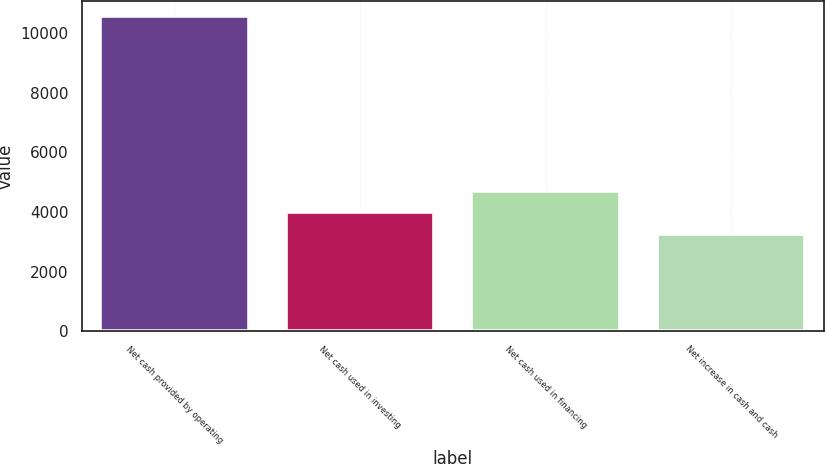Convert chart. <chart><loc_0><loc_0><loc_500><loc_500><bar_chart><fcel>Net cash provided by operating<fcel>Net cash used in investing<fcel>Net cash used in financing<fcel>Net increase in cash and cash<nl><fcel>10571<fcel>3989.3<fcel>4720.6<fcel>3258<nl></chart> 